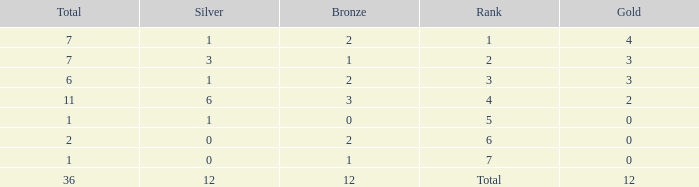What is the number of bronze medals when there are fewer than 0 silver medals? None. 